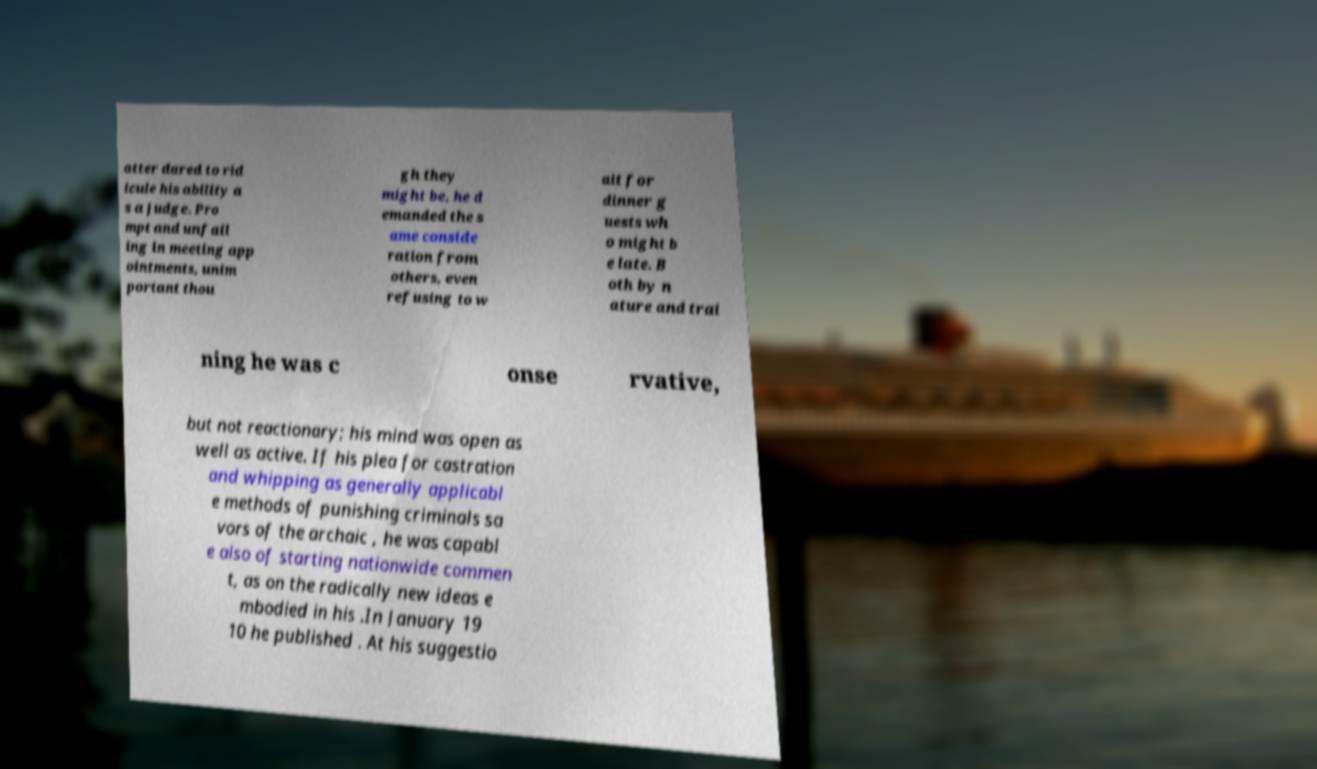For documentation purposes, I need the text within this image transcribed. Could you provide that? atter dared to rid icule his ability a s a judge. Pro mpt and unfail ing in meeting app ointments, unim portant thou gh they might be, he d emanded the s ame conside ration from others, even refusing to w ait for dinner g uests wh o might b e late. B oth by n ature and trai ning he was c onse rvative, but not reactionary; his mind was open as well as active. If his plea for castration and whipping as generally applicabl e methods of punishing criminals sa vors of the archaic , he was capabl e also of starting nationwide commen t, as on the radically new ideas e mbodied in his .In January 19 10 he published . At his suggestio 